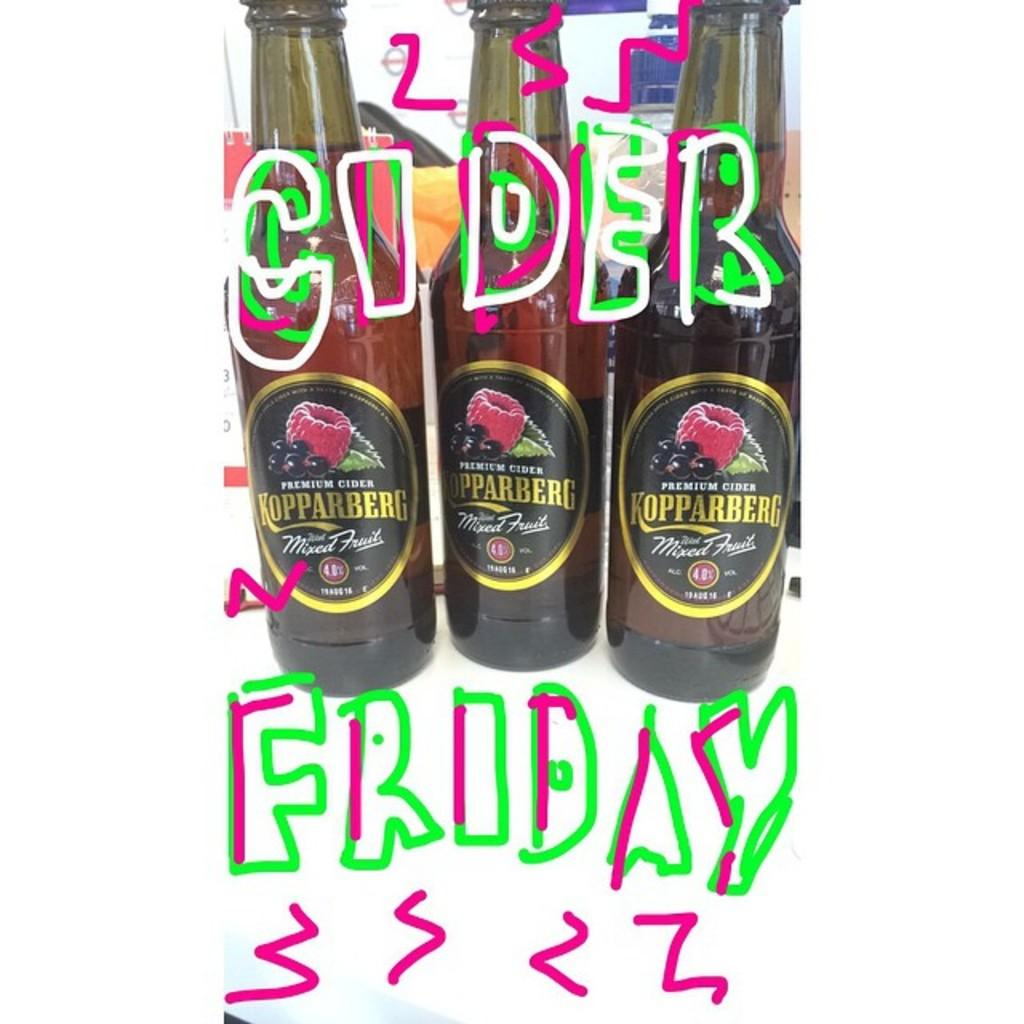What type of containers are visible in the image? There are bottles filled with drink in the image. Are there any specific labels or markings on the bottles? Yes, some of the bottles have "Friday" written on them, and some have "cider" written on them. Can you see the queen playing a drum in the image? No, there is no queen or drum present in the image. The image only features bottles filled with drink. 